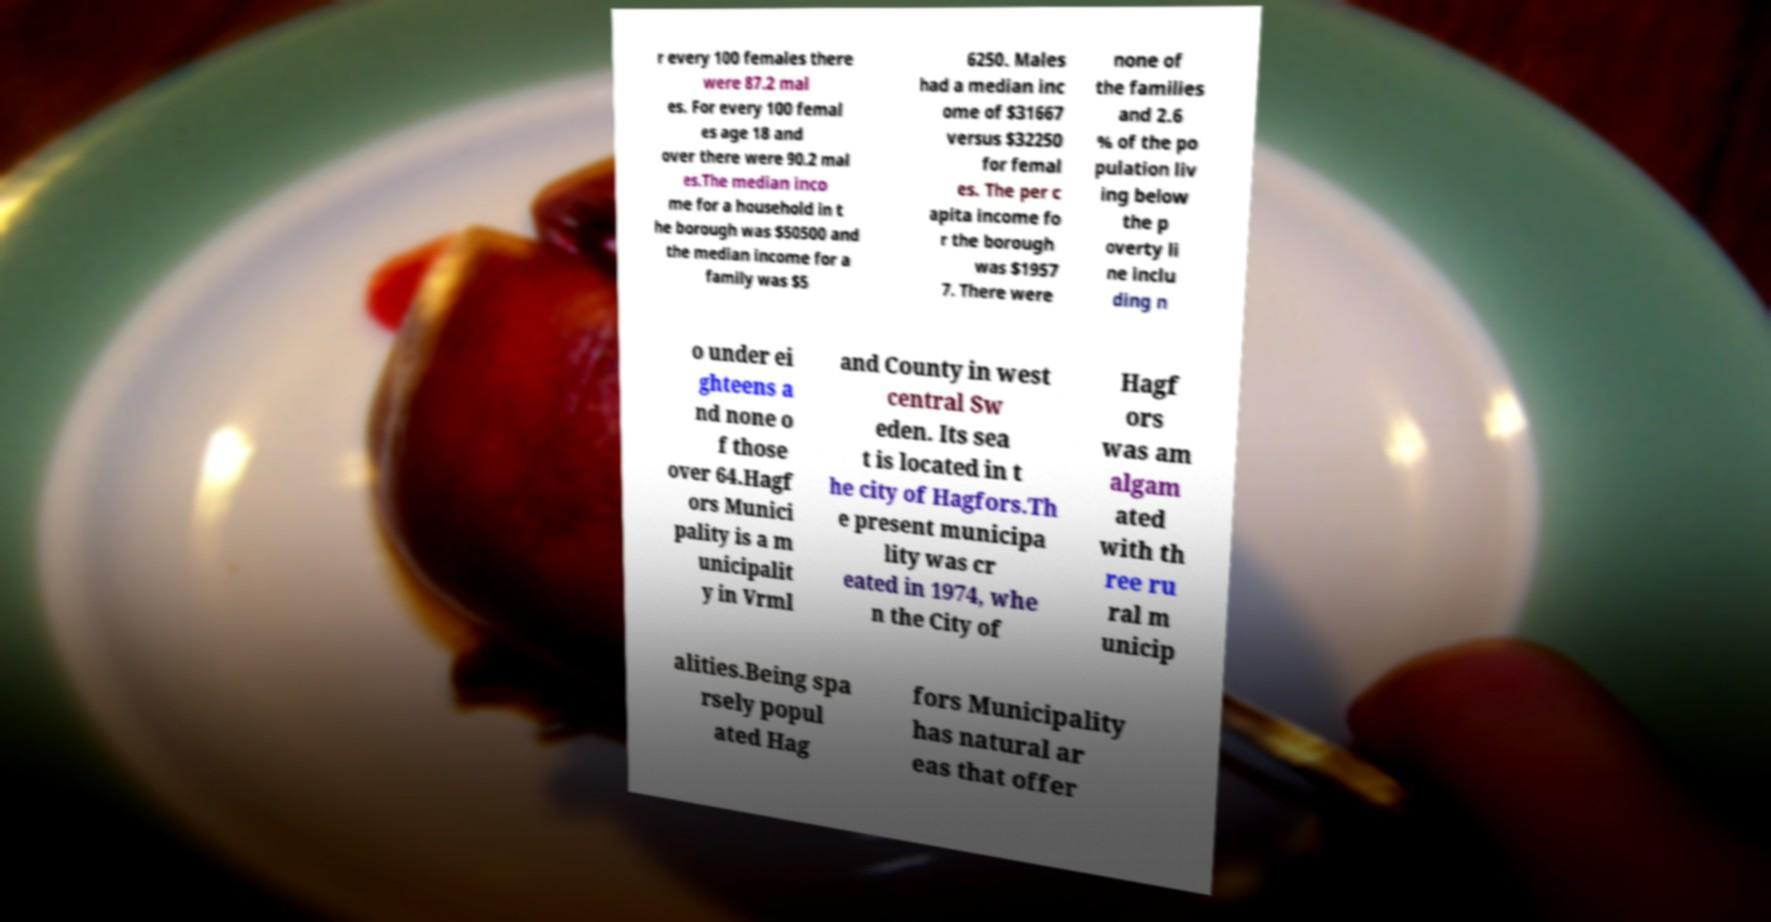Please identify and transcribe the text found in this image. r every 100 females there were 87.2 mal es. For every 100 femal es age 18 and over there were 90.2 mal es.The median inco me for a household in t he borough was $50500 and the median income for a family was $5 6250. Males had a median inc ome of $31667 versus $32250 for femal es. The per c apita income fo r the borough was $1957 7. There were none of the families and 2.6 % of the po pulation liv ing below the p overty li ne inclu ding n o under ei ghteens a nd none o f those over 64.Hagf ors Munici pality is a m unicipalit y in Vrml and County in west central Sw eden. Its sea t is located in t he city of Hagfors.Th e present municipa lity was cr eated in 1974, whe n the City of Hagf ors was am algam ated with th ree ru ral m unicip alities.Being spa rsely popul ated Hag fors Municipality has natural ar eas that offer 